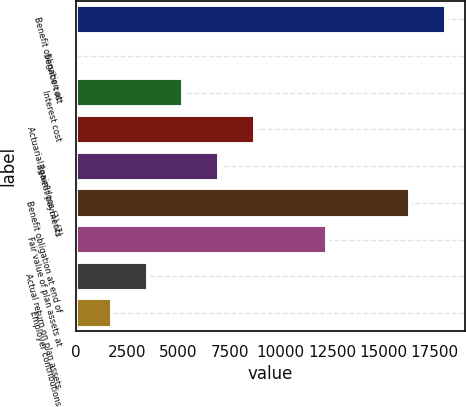Convert chart. <chart><loc_0><loc_0><loc_500><loc_500><bar_chart><fcel>Benefit obligation at<fcel>Service cost<fcel>Interest cost<fcel>Actuarial (gain) loss (1) (2)<fcel>Benefit payments<fcel>Benefit obligation at end of<fcel>Fair value of plan assets at<fcel>Actual return on plan assets<fcel>Employer contributions<nl><fcel>18060.2<fcel>2<fcel>5252.6<fcel>8753<fcel>7002.8<fcel>16310<fcel>12253.4<fcel>3502.4<fcel>1752.2<nl></chart> 